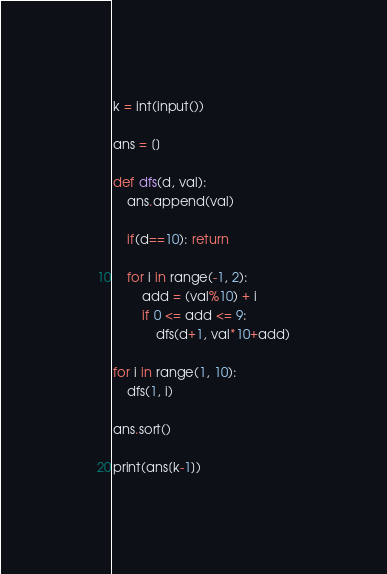Convert code to text. <code><loc_0><loc_0><loc_500><loc_500><_Python_>k = int(input())

ans = []

def dfs(d, val):
    ans.append(val)

    if(d==10): return

    for i in range(-1, 2):
        add = (val%10) + i
        if 0 <= add <= 9:
            dfs(d+1, val*10+add)

for i in range(1, 10):
    dfs(1, i)

ans.sort()

print(ans[k-1])
</code> 